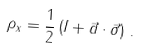Convert formula to latex. <formula><loc_0><loc_0><loc_500><loc_500>\rho _ { x } = \frac { 1 } { 2 } \left ( I + \vec { a } \cdot \vec { \sigma } \right ) \, .</formula> 